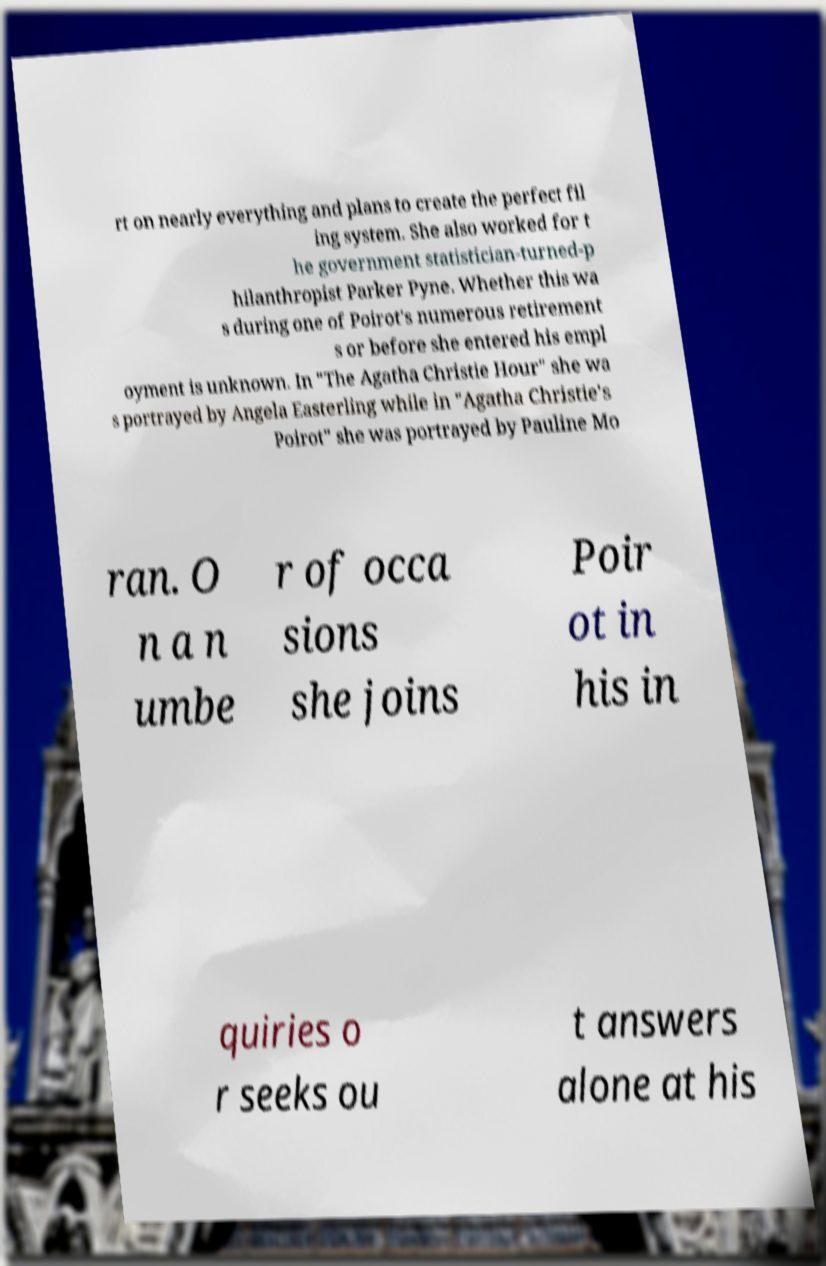Can you read and provide the text displayed in the image?This photo seems to have some interesting text. Can you extract and type it out for me? rt on nearly everything and plans to create the perfect fil ing system. She also worked for t he government statistician-turned-p hilanthropist Parker Pyne. Whether this wa s during one of Poirot's numerous retirement s or before she entered his empl oyment is unknown. In "The Agatha Christie Hour" she wa s portrayed by Angela Easterling while in "Agatha Christie's Poirot" she was portrayed by Pauline Mo ran. O n a n umbe r of occa sions she joins Poir ot in his in quiries o r seeks ou t answers alone at his 